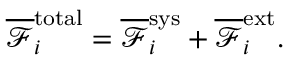Convert formula to latex. <formula><loc_0><loc_0><loc_500><loc_500>\overline { { \mathcal { F } } } _ { i } ^ { t o t a l } = \overline { { \mathcal { F } } } _ { i } ^ { s y s } + \overline { { \mathcal { F } } } _ { i } ^ { e x t } .</formula> 